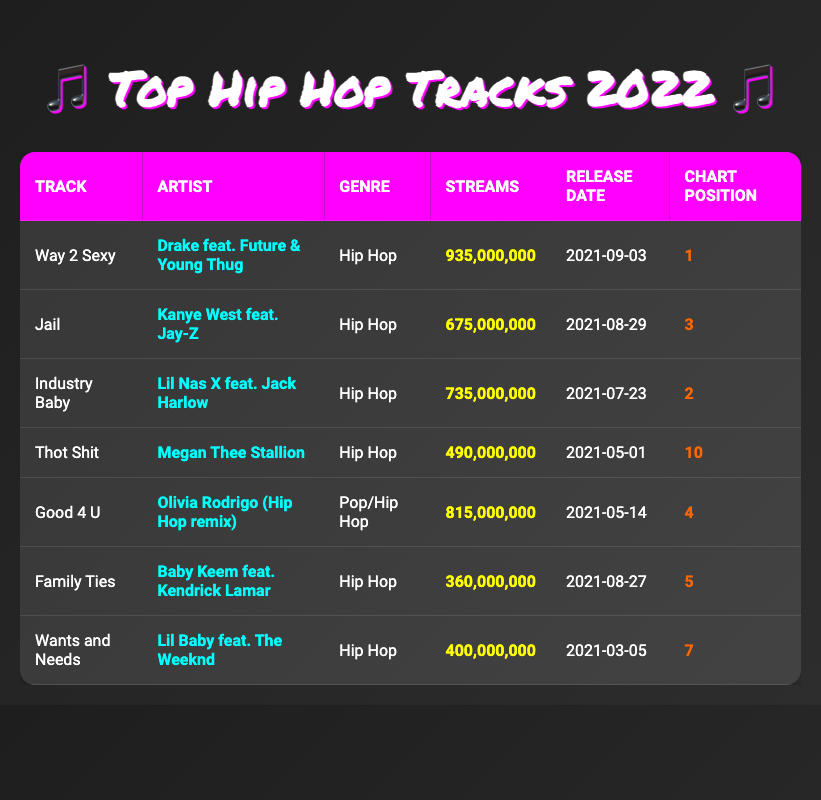What is the track with the most streams? The table shows the tracks and their respective stream counts. The highest stream count is 935,000,000 for the track "Way 2 Sexy" by Drake feat. Future & Young Thug.
Answer: Way 2 Sexy Which artist features in the track "Jail"? Looking at the row for "Jail," the artist listed is Kanye West feat. Jay-Z.
Answer: Kanye West feat. Jay-Z What is the total number of streams for the top three tracks? To find the total streams for the top three tracks, I add the streams of "Way 2 Sexy" (935,000,000), "Industry Baby" (735,000,000), and "Jail" (675,000,000): 935,000,000 + 735,000,000 + 675,000,000 = 2,345,000,000.
Answer: 2,345,000,000 Is "Good 4 U" considered a Hip Hop track? The table categorizes "Good 4 U" as a Pop/Hip Hop track. So, it is partially recognized in the Hip Hop genre.
Answer: No Which hip hop track has the lowest streams? The track "Family Ties" has the lowest stream count among the listed hip hop tracks with a total of 360,000,000 streams.
Answer: Family Ties What is the average number of streams for the hip hop tracks listed? To find the average, sum the streams of all hip hop tracks: (935,000,000 + 675,000,000 + 735,000,000 + 490,000,000 + 360,000,000 + 400,000,000) = 3,595,000,000. There are 6 hip hop tracks, so the average is 3,595,000,000 / 6 = 599,166,667.
Answer: 599,166,667 Which track was released the latest? The release dates are listed, and the most recent release is "Way 2 Sexy," which came out on 2021-09-03.
Answer: Way 2 Sexy How many tracks reached the top 5 chart positions in the hip hop genre? The tracks within the top 5 chart positions specifically in the hip hop genre are "Way 2 Sexy," "Industry Baby," "Jail," "Family Ties," and "Wants and Needs." Counting these gives us 5 tracks in total.
Answer: 5 Was "Thot Shit" released before "Good 4 U"? "Thot Shit" was released on 2021-05-01 and "Good 4 U" was released on 2021-05-14. Since May 1 is earlier than May 14, "Thot Shit" was released first.
Answer: Yes 